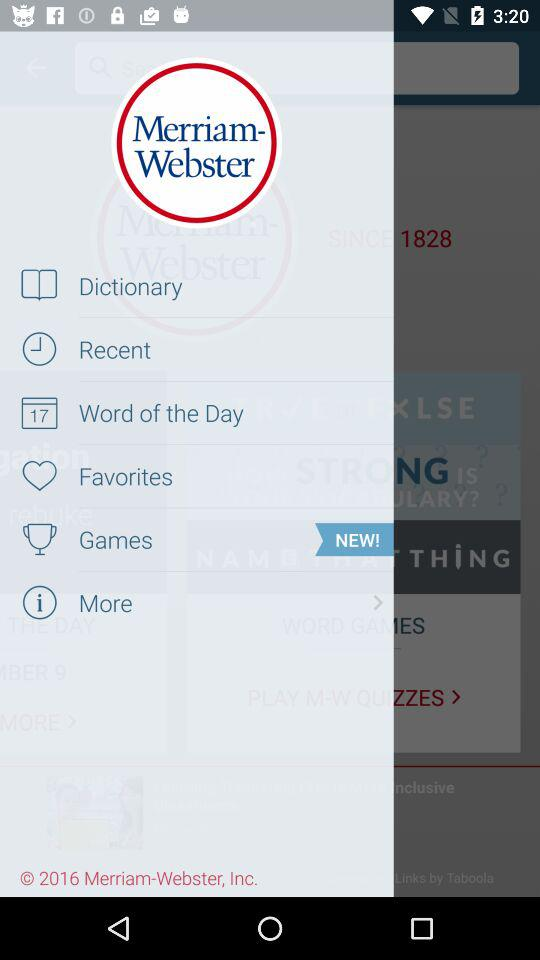Which option has received a fresh nomination?
When the provided information is insufficient, respond with <no answer>. <no answer> 